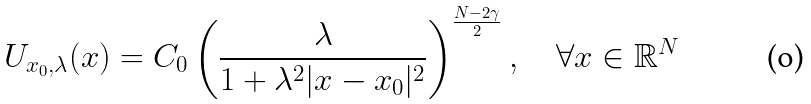<formula> <loc_0><loc_0><loc_500><loc_500>U _ { x _ { 0 } , \lambda } ( x ) = C _ { 0 } \left ( \frac { \lambda } { 1 + \lambda ^ { 2 } | x - x _ { 0 } | ^ { 2 } } \right ) ^ { \frac { N - 2 \gamma } { 2 } } , \quad \forall x \in \mathbb { R } ^ { N }</formula> 